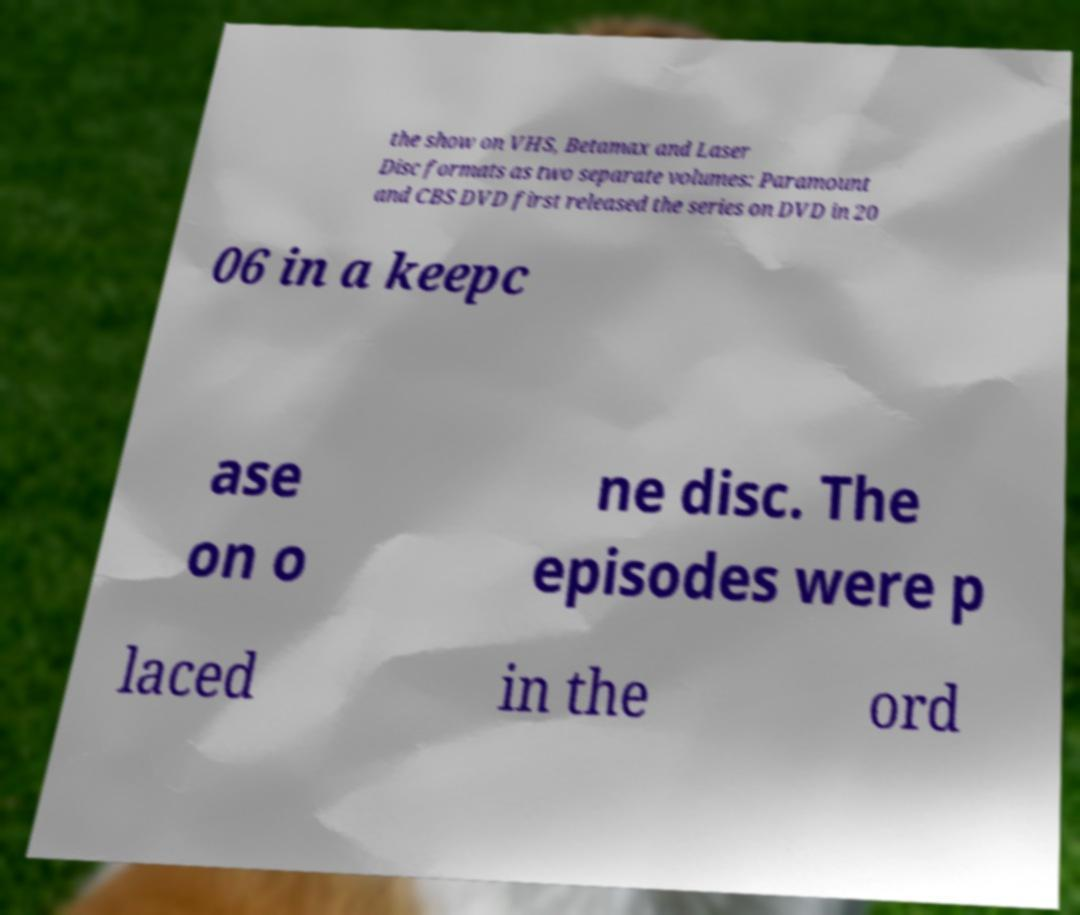Please identify and transcribe the text found in this image. the show on VHS, Betamax and Laser Disc formats as two separate volumes: Paramount and CBS DVD first released the series on DVD in 20 06 in a keepc ase on o ne disc. The episodes were p laced in the ord 